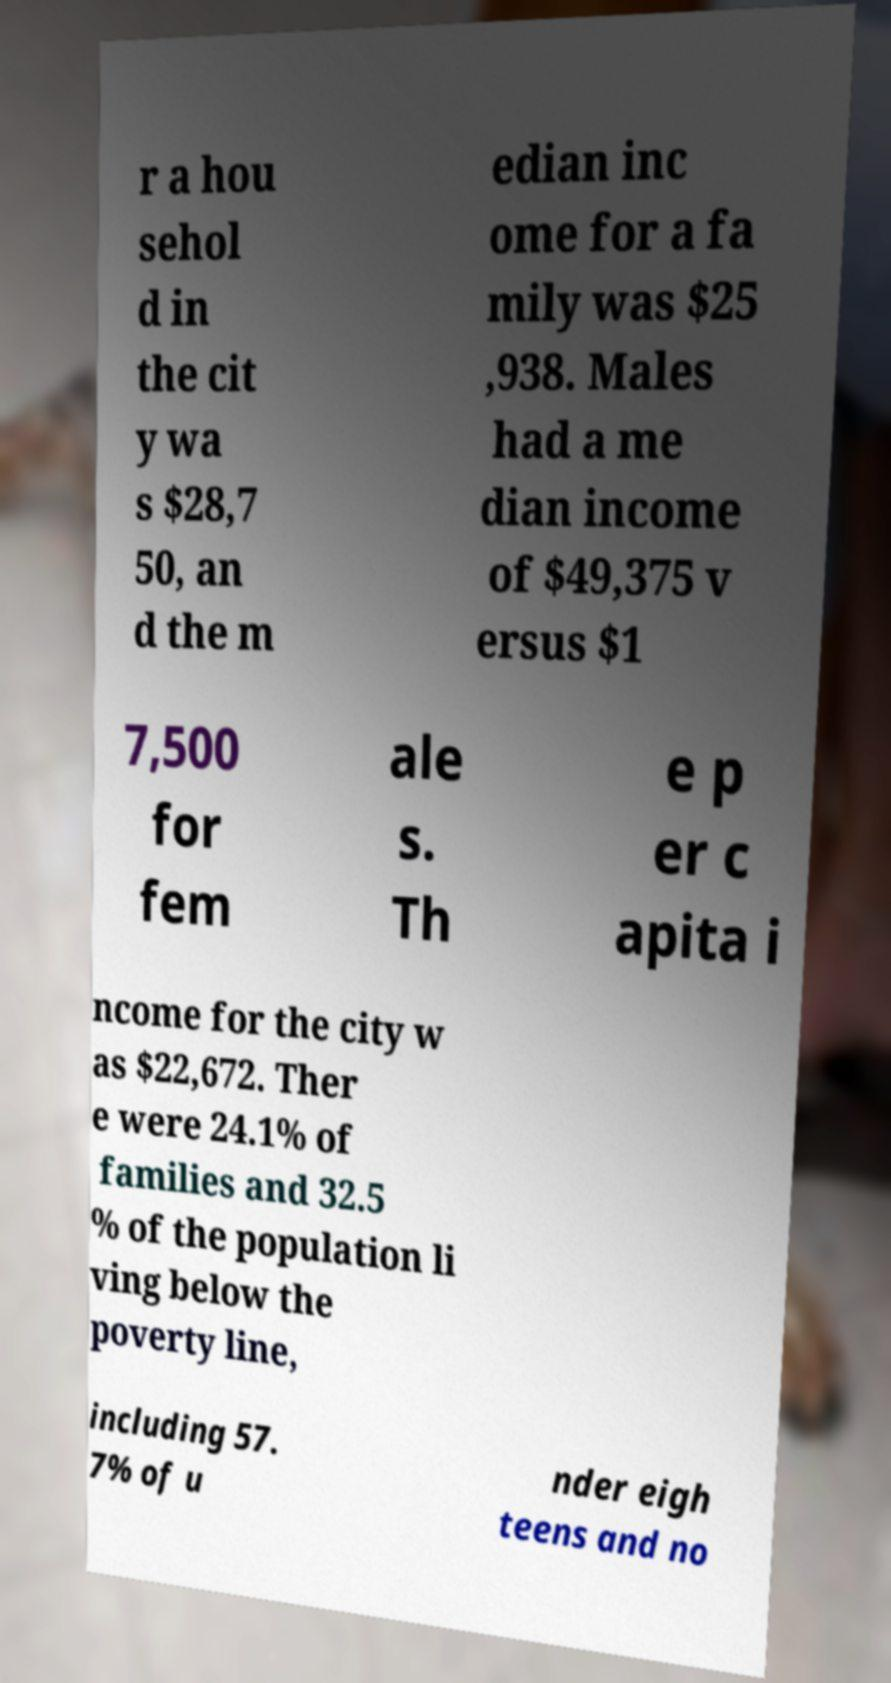I need the written content from this picture converted into text. Can you do that? r a hou sehol d in the cit y wa s $28,7 50, an d the m edian inc ome for a fa mily was $25 ,938. Males had a me dian income of $49,375 v ersus $1 7,500 for fem ale s. Th e p er c apita i ncome for the city w as $22,672. Ther e were 24.1% of families and 32.5 % of the population li ving below the poverty line, including 57. 7% of u nder eigh teens and no 